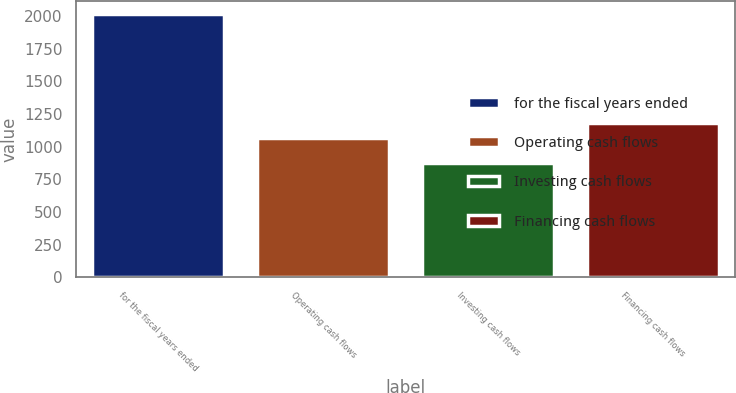Convert chart to OTSL. <chart><loc_0><loc_0><loc_500><loc_500><bar_chart><fcel>for the fiscal years ended<fcel>Operating cash flows<fcel>Investing cash flows<fcel>Financing cash flows<nl><fcel>2012<fcel>1066.2<fcel>873.4<fcel>1180.06<nl></chart> 